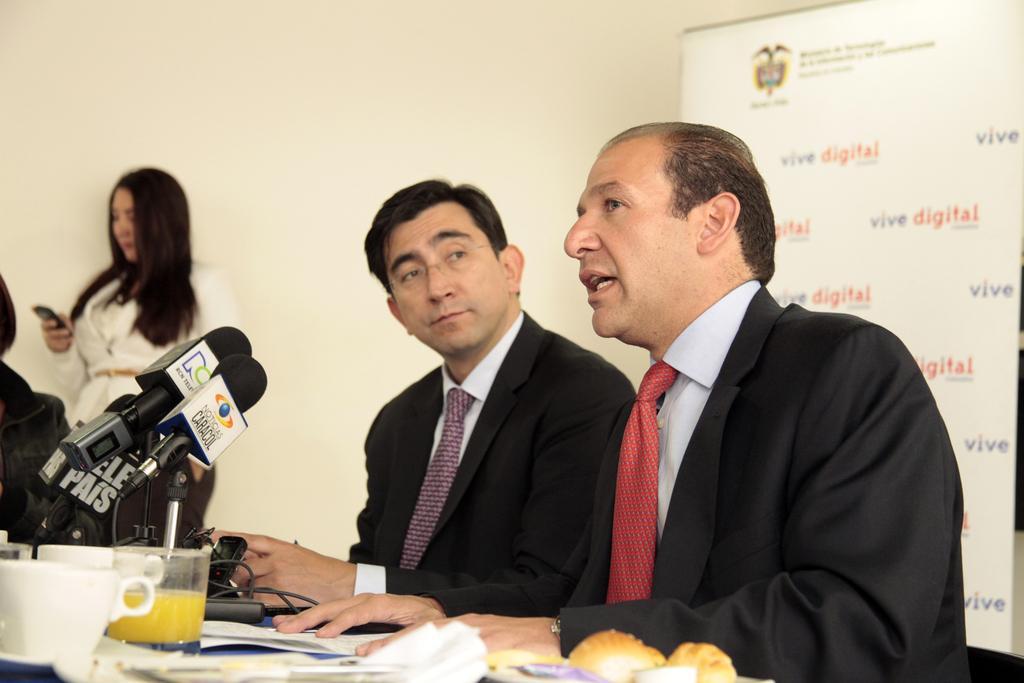How would you summarize this image in a sentence or two? In this image we can see a few people in a room and among them one person is talking and in front of him there is a table and on the table, we can see the microphones, cups, food items and other objects. In the background, we can see the wall and poster with some text. 